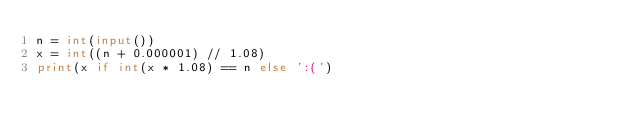<code> <loc_0><loc_0><loc_500><loc_500><_Python_>n = int(input())
x = int((n + 0.000001) // 1.08)
print(x if int(x * 1.08) == n else ':(')
</code> 